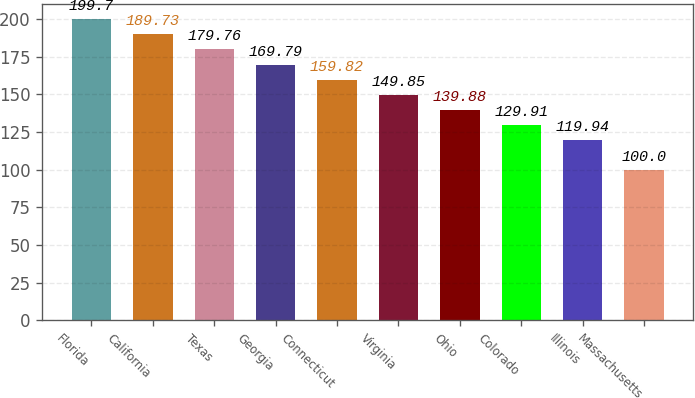Convert chart to OTSL. <chart><loc_0><loc_0><loc_500><loc_500><bar_chart><fcel>Florida<fcel>California<fcel>Texas<fcel>Georgia<fcel>Connecticut<fcel>Virginia<fcel>Ohio<fcel>Colorado<fcel>Illinois<fcel>Massachusetts<nl><fcel>199.7<fcel>189.73<fcel>179.76<fcel>169.79<fcel>159.82<fcel>149.85<fcel>139.88<fcel>129.91<fcel>119.94<fcel>100<nl></chart> 